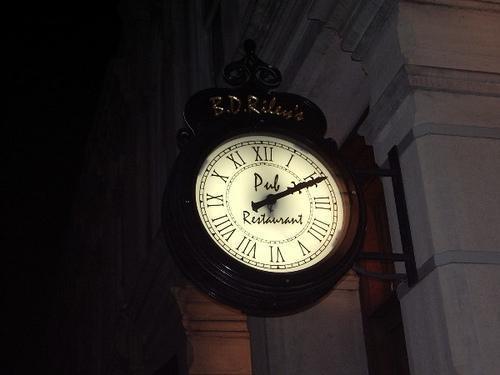How many clocks are in the photo?
Give a very brief answer. 1. 